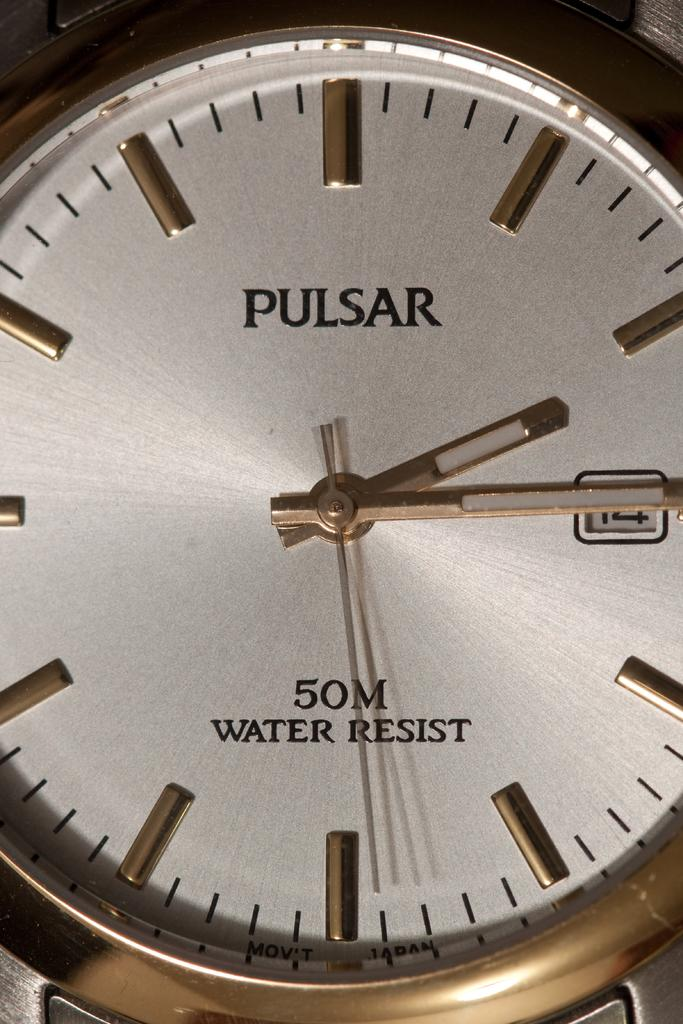<image>
Write a terse but informative summary of the picture. A Pulsar brand watch shows that it is 50 m water resistant. 